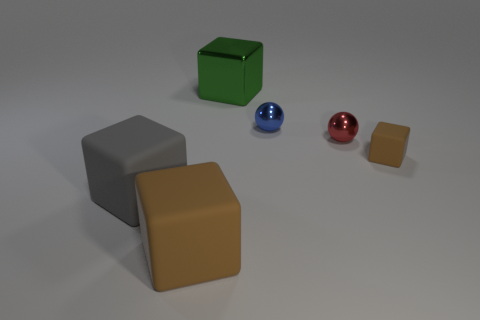Add 3 gray blocks. How many objects exist? 9 Subtract all blocks. How many objects are left? 2 Add 5 large gray matte objects. How many large gray matte objects exist? 6 Subtract 1 gray blocks. How many objects are left? 5 Subtract all large brown cylinders. Subtract all tiny blue objects. How many objects are left? 5 Add 4 big brown blocks. How many big brown blocks are left? 5 